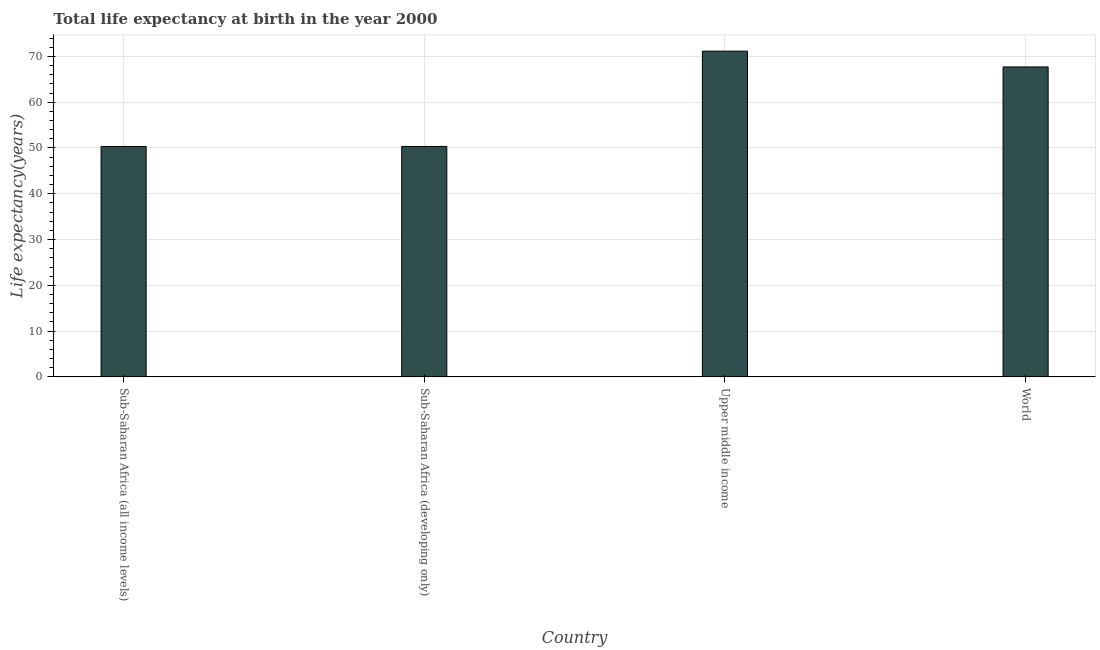What is the title of the graph?
Your answer should be very brief. Total life expectancy at birth in the year 2000. What is the label or title of the Y-axis?
Your response must be concise. Life expectancy(years). What is the life expectancy at birth in World?
Offer a very short reply. 67.7. Across all countries, what is the maximum life expectancy at birth?
Your response must be concise. 71.15. Across all countries, what is the minimum life expectancy at birth?
Offer a terse response. 50.34. In which country was the life expectancy at birth maximum?
Keep it short and to the point. Upper middle income. In which country was the life expectancy at birth minimum?
Keep it short and to the point. Sub-Saharan Africa (developing only). What is the sum of the life expectancy at birth?
Provide a short and direct response. 239.54. What is the average life expectancy at birth per country?
Offer a terse response. 59.88. What is the median life expectancy at birth?
Offer a terse response. 59.02. What is the ratio of the life expectancy at birth in Sub-Saharan Africa (all income levels) to that in Upper middle income?
Keep it short and to the point. 0.71. What is the difference between the highest and the second highest life expectancy at birth?
Make the answer very short. 3.45. Is the sum of the life expectancy at birth in Sub-Saharan Africa (developing only) and World greater than the maximum life expectancy at birth across all countries?
Provide a short and direct response. Yes. What is the difference between the highest and the lowest life expectancy at birth?
Make the answer very short. 20.82. In how many countries, is the life expectancy at birth greater than the average life expectancy at birth taken over all countries?
Your answer should be very brief. 2. How many bars are there?
Provide a succinct answer. 4. How many countries are there in the graph?
Give a very brief answer. 4. What is the difference between two consecutive major ticks on the Y-axis?
Give a very brief answer. 10. What is the Life expectancy(years) of Sub-Saharan Africa (all income levels)?
Your answer should be compact. 50.34. What is the Life expectancy(years) in Sub-Saharan Africa (developing only)?
Your response must be concise. 50.34. What is the Life expectancy(years) of Upper middle income?
Make the answer very short. 71.15. What is the Life expectancy(years) in World?
Ensure brevity in your answer.  67.7. What is the difference between the Life expectancy(years) in Sub-Saharan Africa (all income levels) and Sub-Saharan Africa (developing only)?
Give a very brief answer. 0. What is the difference between the Life expectancy(years) in Sub-Saharan Africa (all income levels) and Upper middle income?
Provide a short and direct response. -20.81. What is the difference between the Life expectancy(years) in Sub-Saharan Africa (all income levels) and World?
Ensure brevity in your answer.  -17.37. What is the difference between the Life expectancy(years) in Sub-Saharan Africa (developing only) and Upper middle income?
Make the answer very short. -20.82. What is the difference between the Life expectancy(years) in Sub-Saharan Africa (developing only) and World?
Provide a short and direct response. -17.37. What is the difference between the Life expectancy(years) in Upper middle income and World?
Provide a short and direct response. 3.45. What is the ratio of the Life expectancy(years) in Sub-Saharan Africa (all income levels) to that in Sub-Saharan Africa (developing only)?
Offer a very short reply. 1. What is the ratio of the Life expectancy(years) in Sub-Saharan Africa (all income levels) to that in Upper middle income?
Make the answer very short. 0.71. What is the ratio of the Life expectancy(years) in Sub-Saharan Africa (all income levels) to that in World?
Ensure brevity in your answer.  0.74. What is the ratio of the Life expectancy(years) in Sub-Saharan Africa (developing only) to that in Upper middle income?
Offer a terse response. 0.71. What is the ratio of the Life expectancy(years) in Sub-Saharan Africa (developing only) to that in World?
Keep it short and to the point. 0.74. What is the ratio of the Life expectancy(years) in Upper middle income to that in World?
Ensure brevity in your answer.  1.05. 